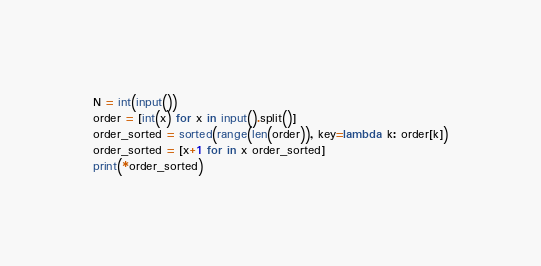Convert code to text. <code><loc_0><loc_0><loc_500><loc_500><_Python_>N = int(input())
order = [int(x) for x in input().split()]
order_sorted = sorted(range(len(order)), key=lambda k: order[k])
order_sorted = [x+1 for in x order_sorted]
print(*order_sorted)</code> 